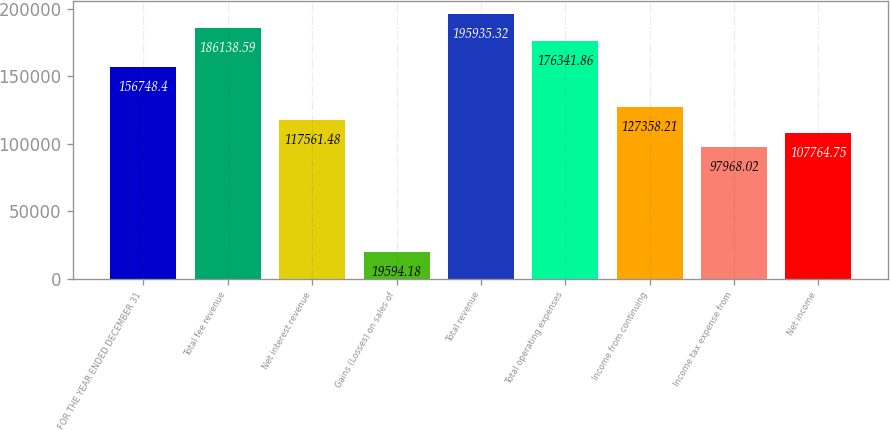<chart> <loc_0><loc_0><loc_500><loc_500><bar_chart><fcel>FOR THE YEAR ENDED DECEMBER 31<fcel>Total fee revenue<fcel>Net interest revenue<fcel>Gains (Losses) on sales of<fcel>Total revenue<fcel>Total operating expenses<fcel>Income from continuing<fcel>Income tax expense from<fcel>Net income<nl><fcel>156748<fcel>186139<fcel>117561<fcel>19594.2<fcel>195935<fcel>176342<fcel>127358<fcel>97968<fcel>107765<nl></chart> 